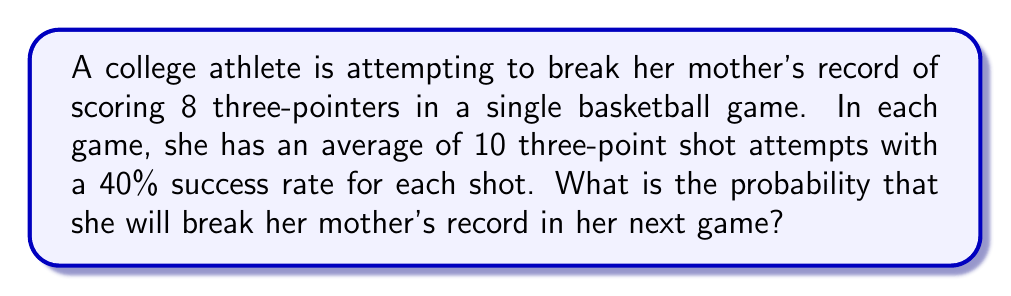Provide a solution to this math problem. To solve this problem, we need to use the binomial probability distribution. We want to find the probability of scoring 9 or more three-pointers out of 10 attempts.

Let's break it down step-by-step:

1) We have:
   $n = 10$ (number of attempts)
   $p = 0.40$ (probability of success for each attempt)
   $X = $ number of successful three-pointers

2) We need to find $P(X \geq 9)$, which is equal to $P(X = 9) + P(X = 10)$

3) The binomial probability formula is:

   $P(X = k) = \binom{n}{k} p^k (1-p)^{n-k}$

4) For $P(X = 9)$:
   $P(X = 9) = \binom{10}{9} (0.40)^9 (0.60)^1$
              $= 10 \cdot (0.40)^9 \cdot 0.60$
              $\approx 0.0016$

5) For $P(X = 10)$:
   $P(X = 10) = \binom{10}{10} (0.40)^{10} (0.60)^0$
               $= 1 \cdot (0.40)^{10}$
               $\approx 0.0001$

6) Therefore, $P(X \geq 9) = P(X = 9) + P(X = 10)$
                            $\approx 0.0016 + 0.0001$
                            $\approx 0.0017$
Answer: The probability that the athlete will break her mother's record in her next game is approximately 0.0017 or 0.17%. 